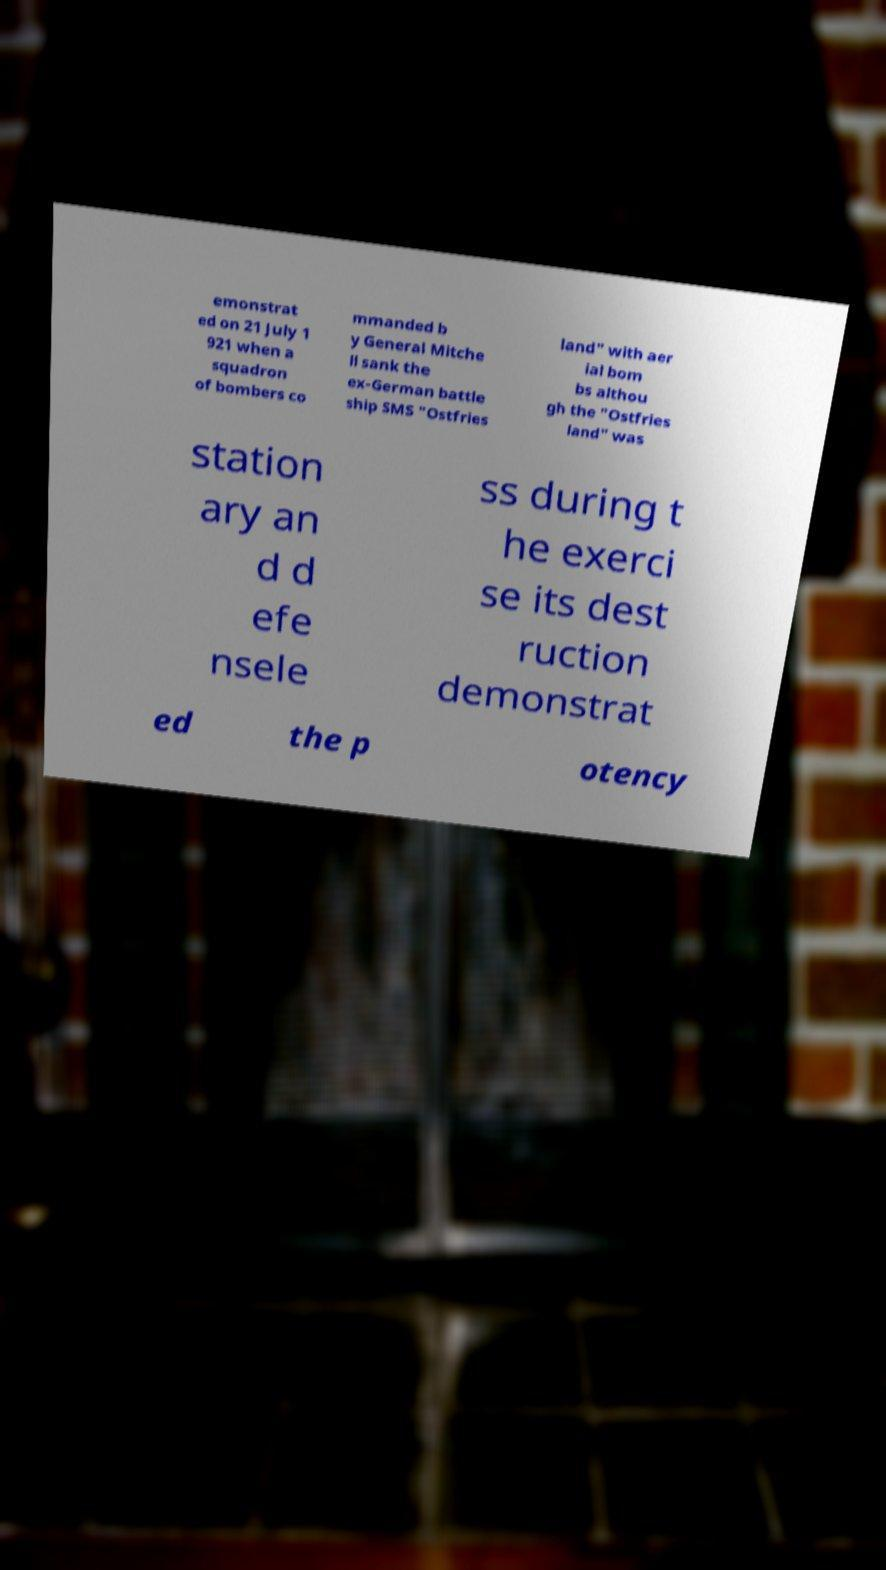Can you accurately transcribe the text from the provided image for me? emonstrat ed on 21 July 1 921 when a squadron of bombers co mmanded b y General Mitche ll sank the ex-German battle ship SMS "Ostfries land" with aer ial bom bs althou gh the "Ostfries land" was station ary an d d efe nsele ss during t he exerci se its dest ruction demonstrat ed the p otency 